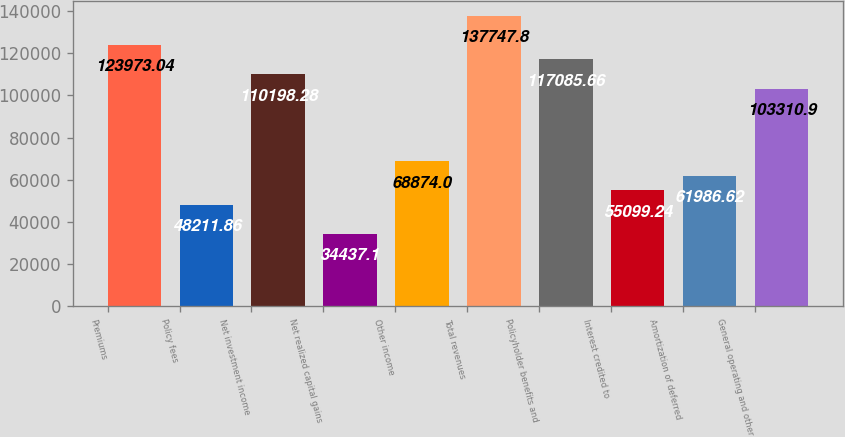<chart> <loc_0><loc_0><loc_500><loc_500><bar_chart><fcel>Premiums<fcel>Policy fees<fcel>Net investment income<fcel>Net realized capital gains<fcel>Other income<fcel>Total revenues<fcel>Policyholder benefits and<fcel>Interest credited to<fcel>Amortization of deferred<fcel>General operating and other<nl><fcel>123973<fcel>48211.9<fcel>110198<fcel>34437.1<fcel>68874<fcel>137748<fcel>117086<fcel>55099.2<fcel>61986.6<fcel>103311<nl></chart> 